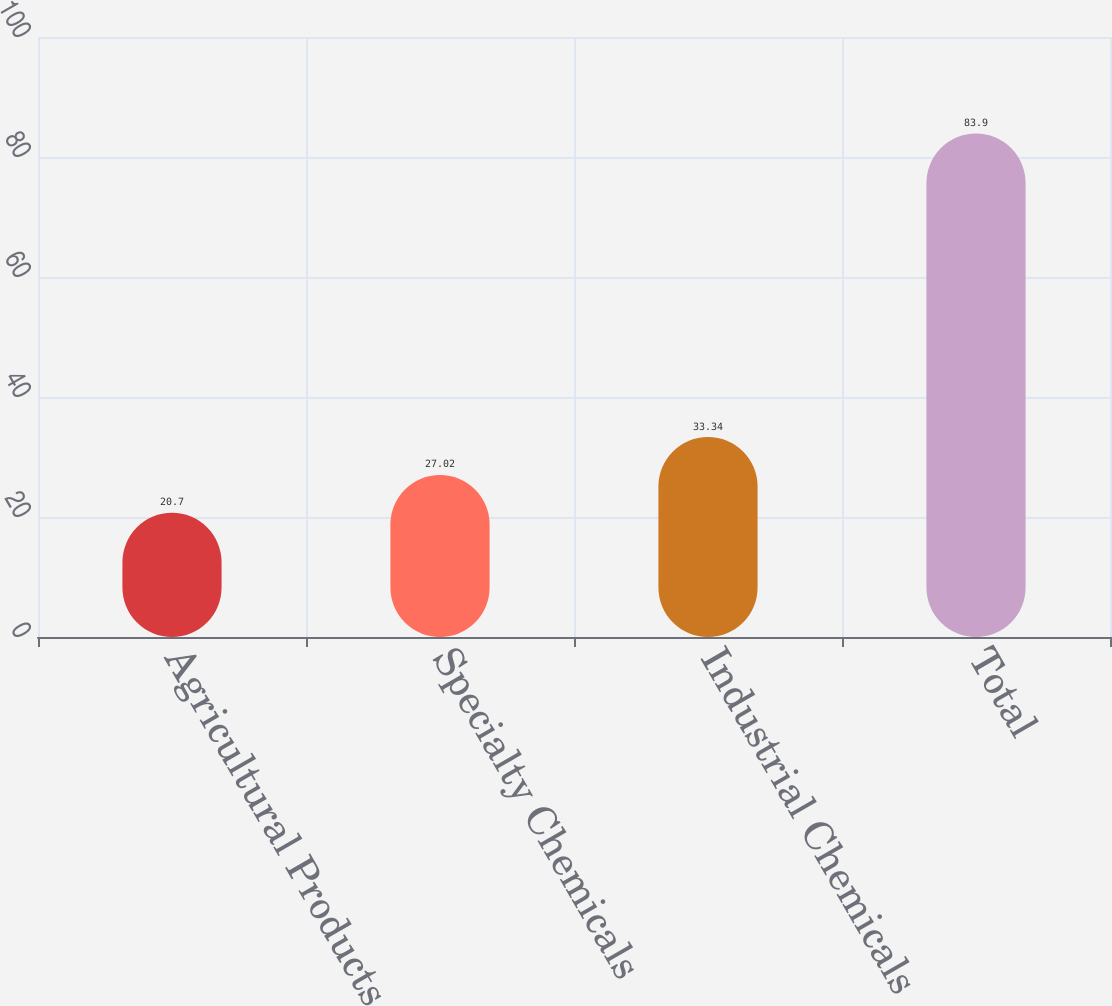Convert chart. <chart><loc_0><loc_0><loc_500><loc_500><bar_chart><fcel>Agricultural Products<fcel>Specialty Chemicals<fcel>Industrial Chemicals<fcel>Total<nl><fcel>20.7<fcel>27.02<fcel>33.34<fcel>83.9<nl></chart> 